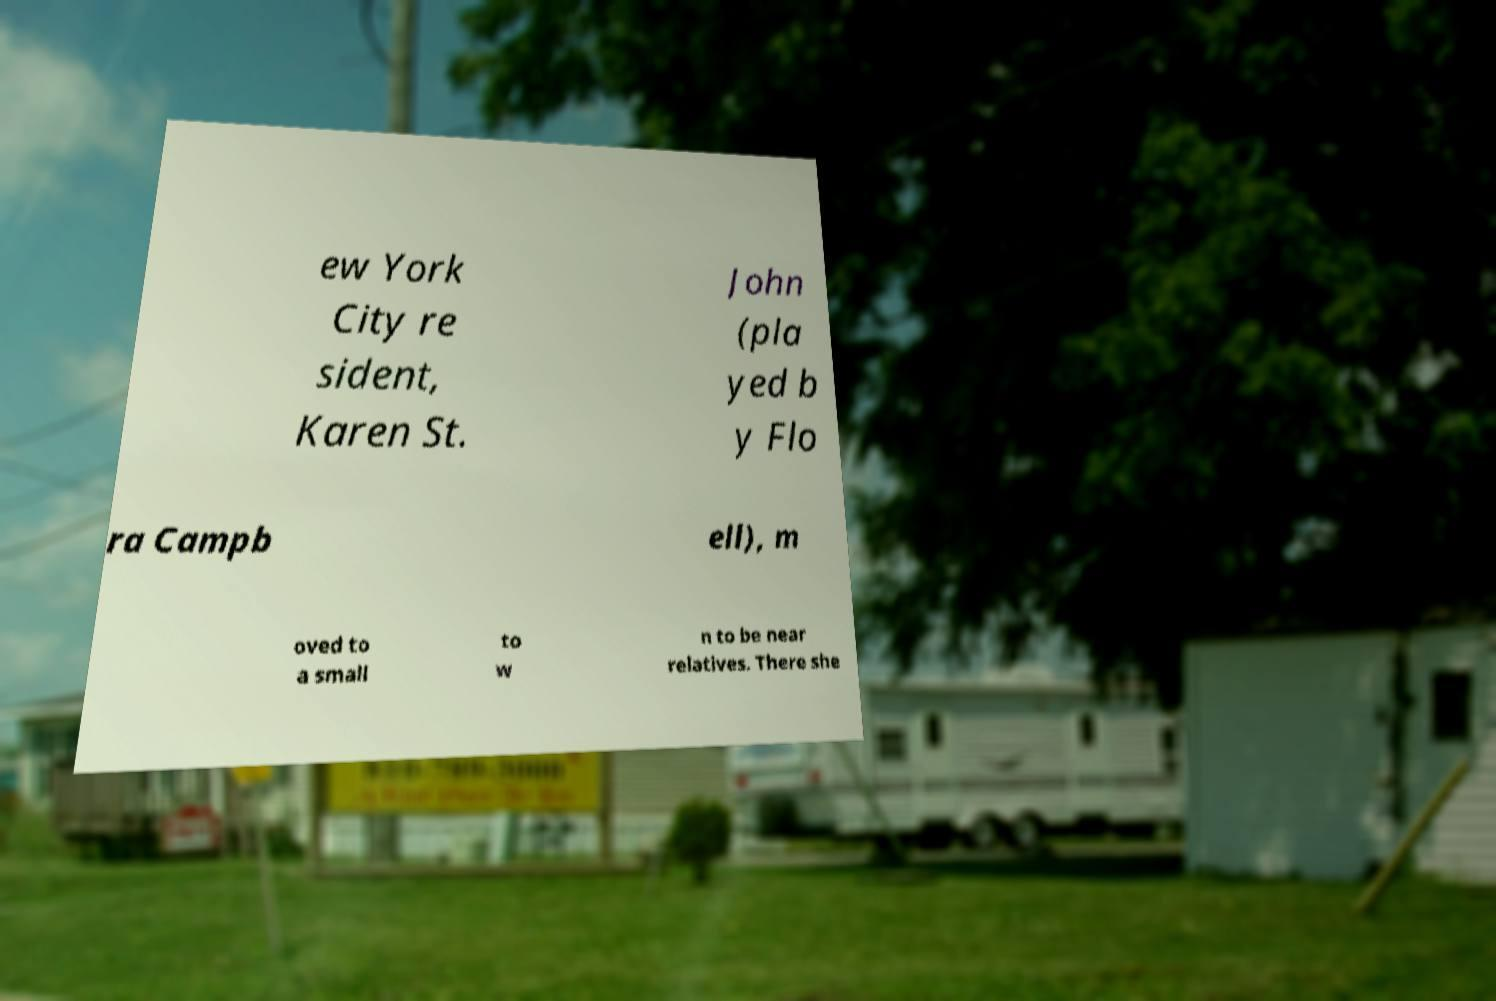Can you read and provide the text displayed in the image?This photo seems to have some interesting text. Can you extract and type it out for me? ew York City re sident, Karen St. John (pla yed b y Flo ra Campb ell), m oved to a small to w n to be near relatives. There she 